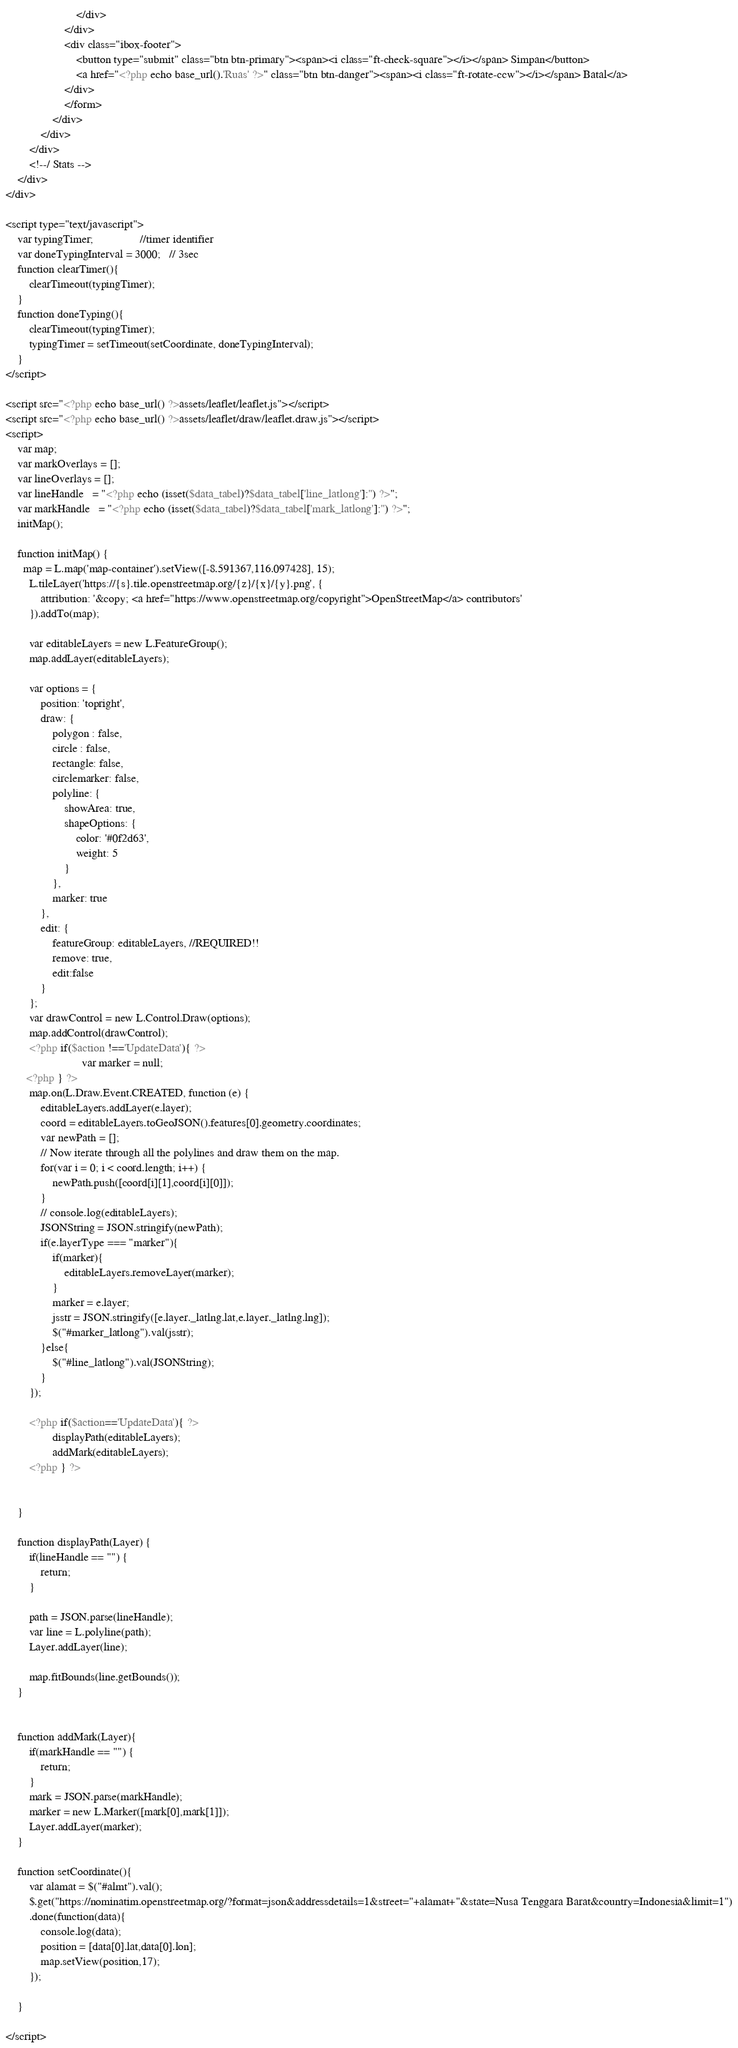Convert code to text. <code><loc_0><loc_0><loc_500><loc_500><_PHP_>                        </div>
                    </div>
                    <div class="ibox-footer">
                        <button type="submit" class="btn btn-primary"><span><i class="ft-check-square"></i></span> Simpan</button>
                        <a href="<?php echo base_url().'Ruas' ?>" class="btn btn-danger"><span><i class="ft-rotate-ccw"></i></span> Batal</a>
                    </div>
                    </form>                     
                </div>
            </div>
        </div>
        <!--/ Stats -->
    </div>
</div>

<script type="text/javascript">
    var typingTimer;                //timer identifier
    var doneTypingInterval = 3000;   // 3sec
    function clearTimer(){
        clearTimeout(typingTimer);
    }
    function doneTyping(){
        clearTimeout(typingTimer);
        typingTimer = setTimeout(setCoordinate, doneTypingInterval);
    }
</script>

<script src="<?php echo base_url() ?>assets/leaflet/leaflet.js"></script>
<script src="<?php echo base_url() ?>assets/leaflet/draw/leaflet.draw.js"></script>
<script>    
    var map;
    var markOverlays = []; 
    var lineOverlays = [];
    var lineHandle   = "<?php echo (isset($data_tabel)?$data_tabel['line_latlong']:'') ?>";
    var markHandle   = "<?php echo (isset($data_tabel)?$data_tabel['mark_latlong']:'') ?>";
    initMap();

    function initMap() {
      map = L.map('map-container').setView([-8.591367,116.097428], 15);
        L.tileLayer('https://{s}.tile.openstreetmap.org/{z}/{x}/{y}.png', {
            attribution: '&copy; <a href="https://www.openstreetmap.org/copyright">OpenStreetMap</a> contributors'
        }).addTo(map);

        var editableLayers = new L.FeatureGroup();
        map.addLayer(editableLayers);

        var options = {
            position: 'topright',
            draw: {
                polygon : false,
                circle : false,
                rectangle: false,
                circlemarker: false,
                polyline: {
                    showArea: true,
                    shapeOptions: {
                        color: '#0f2d63',
                        weight: 5
                    }
                },
                marker: true
            },
            edit: {
                featureGroup: editableLayers, //REQUIRED!!
                remove: true,
                edit:false
            }
        };
        var drawControl = new L.Control.Draw(options);
        map.addControl(drawControl);
        <?php if($action !=='UpdateData'){ ?>
                          var marker = null;
       <?php } ?>
        map.on(L.Draw.Event.CREATED, function (e) {
            editableLayers.addLayer(e.layer);
            coord = editableLayers.toGeoJSON().features[0].geometry.coordinates;
            var newPath = [];        
            // Now iterate through all the polylines and draw them on the map.
            for(var i = 0; i < coord.length; i++) {         
                newPath.push([coord[i][1],coord[i][0]]);           
            }
            // console.log(editableLayers);
            JSONString = JSON.stringify(newPath);
            if(e.layerType === "marker"){
                if(marker){
                    editableLayers.removeLayer(marker);
                }
                marker = e.layer;    
                jsstr = JSON.stringify([e.layer._latlng.lat,e.layer._latlng.lng]);            
                $("#marker_latlong").val(jsstr);
            }else{
                $("#line_latlong").val(JSONString);
            }
        });
       
        <?php if($action=='UpdateData'){ ?>
                displayPath(editableLayers);
                addMark(editableLayers);
        <?php } ?>

        
    }    

    function displayPath(Layer) {
        if(lineHandle == "") {
            return;
        }

        path = JSON.parse(lineHandle);
        var line = L.polyline(path);
        Layer.addLayer(line);

        map.fitBounds(line.getBounds());
    }


    function addMark(Layer){
        if(markHandle == "") {
            return;
        }
        mark = JSON.parse(markHandle);     
        marker = new L.Marker([mark[0],mark[1]]);   
        Layer.addLayer(marker);
    }

    function setCoordinate(){
        var alamat = $("#almt").val();
        $.get("https://nominatim.openstreetmap.org/?format=json&addressdetails=1&street="+alamat+"&state=Nusa Tenggara Barat&country=Indonesia&limit=1")
        .done(function(data){
            console.log(data);
            position = [data[0].lat,data[0].lon];        
            map.setView(position,17);
        });

    }

</script>
</code> 